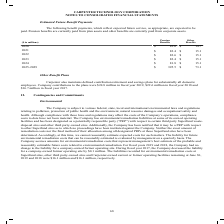According to Carpenter Technology's financial document, How are pension benefits currently paid? currently paid from plan assets and other benefits are currently paid from corporate assets.. The document states: "ate, are expected to be paid. Pension benefits are currently paid from plan assets and other benefits are currently paid from corporate assets...." Also, What is the amount of Estimated pension benefit payments expected in 2020? According to the financial document, $83.0. The relevant text states: "millions) Pension Benefits Other Benefits 2020 $ 83.0 $ 14.7 2021 $ 82.4 $ 15.1 2022 $ 82.6 $ 15.1 2023 $ 82.4 $ 15.1 2024 $ 81.8 $ 15.1 2025-2029 $ 395...." Also, What is the  Pension Benefits and Other Benefits for 2021 respectively? The document shows two values: $82.4 and $15.1 (in millions). From the document: "Benefits Other Benefits 2020 $ 83.0 $ 14.7 2021 $ 82.4 $ 15.1 2022 $ 82.6 $ 15.1 2023 $ 82.4 $ 15.1 2024 $ 81.8 $ 15.1 2025-2029 $ 395.5 $ 73.1 s Othe..." Additionally, In which year from 2020-2024 would the amount for Other Benefits be the lowest? According to the financial document, 2020. The relevant text states: "($ in millions) Pension Benefits Other Benefits 2020 $ 83.0 $ 14.7 2021 $ 82.4 $ 15.1 2022 $ 82.6 $ 15.1 2023 $ 82.4 $ 15.1 2024 $ 81.8 $ 15.1 2025-2029..." Also, can you calculate: What was the change in the amount under other benefits in 2021 from 2020? Based on the calculation: 15.1-14.7, the result is 0.4 (in millions). This is based on the information: "s Other Benefits 2020 $ 83.0 $ 14.7 2021 $ 82.4 $ 15.1 2022 $ 82.6 $ 15.1 2023 $ 82.4 $ 15.1 2024 $ 81.8 $ 15.1 2025-2029 $ 395.5 $ 73.1 ns) Pension Benefits Other Benefits 2020 $ 83.0 $ 14.7 2021 $ 8..." The key data points involved are: 14.7, 15.1. Also, can you calculate: What was the percentage change in the amount under other benefits in 2021 from 2020? To answer this question, I need to perform calculations using the financial data. The calculation is: (15.1-14.7)/14.7, which equals 2.72 (percentage). This is based on the information: "s Other Benefits 2020 $ 83.0 $ 14.7 2021 $ 82.4 $ 15.1 2022 $ 82.6 $ 15.1 2023 $ 82.4 $ 15.1 2024 $ 81.8 $ 15.1 2025-2029 $ 395.5 $ 73.1 ns) Pension Benefits Other Benefits 2020 $ 83.0 $ 14.7 2021 $ 8..." The key data points involved are: 14.7, 15.1. 